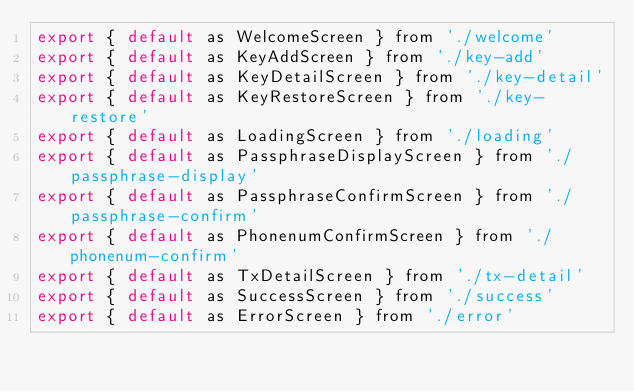<code> <loc_0><loc_0><loc_500><loc_500><_JavaScript_>export { default as WelcomeScreen } from './welcome'
export { default as KeyAddScreen } from './key-add'
export { default as KeyDetailScreen } from './key-detail'
export { default as KeyRestoreScreen } from './key-restore'
export { default as LoadingScreen } from './loading'
export { default as PassphraseDisplayScreen } from './passphrase-display'
export { default as PassphraseConfirmScreen } from './passphrase-confirm'
export { default as PhonenumConfirmScreen } from './phonenum-confirm'
export { default as TxDetailScreen } from './tx-detail'
export { default as SuccessScreen } from './success'
export { default as ErrorScreen } from './error'
</code> 